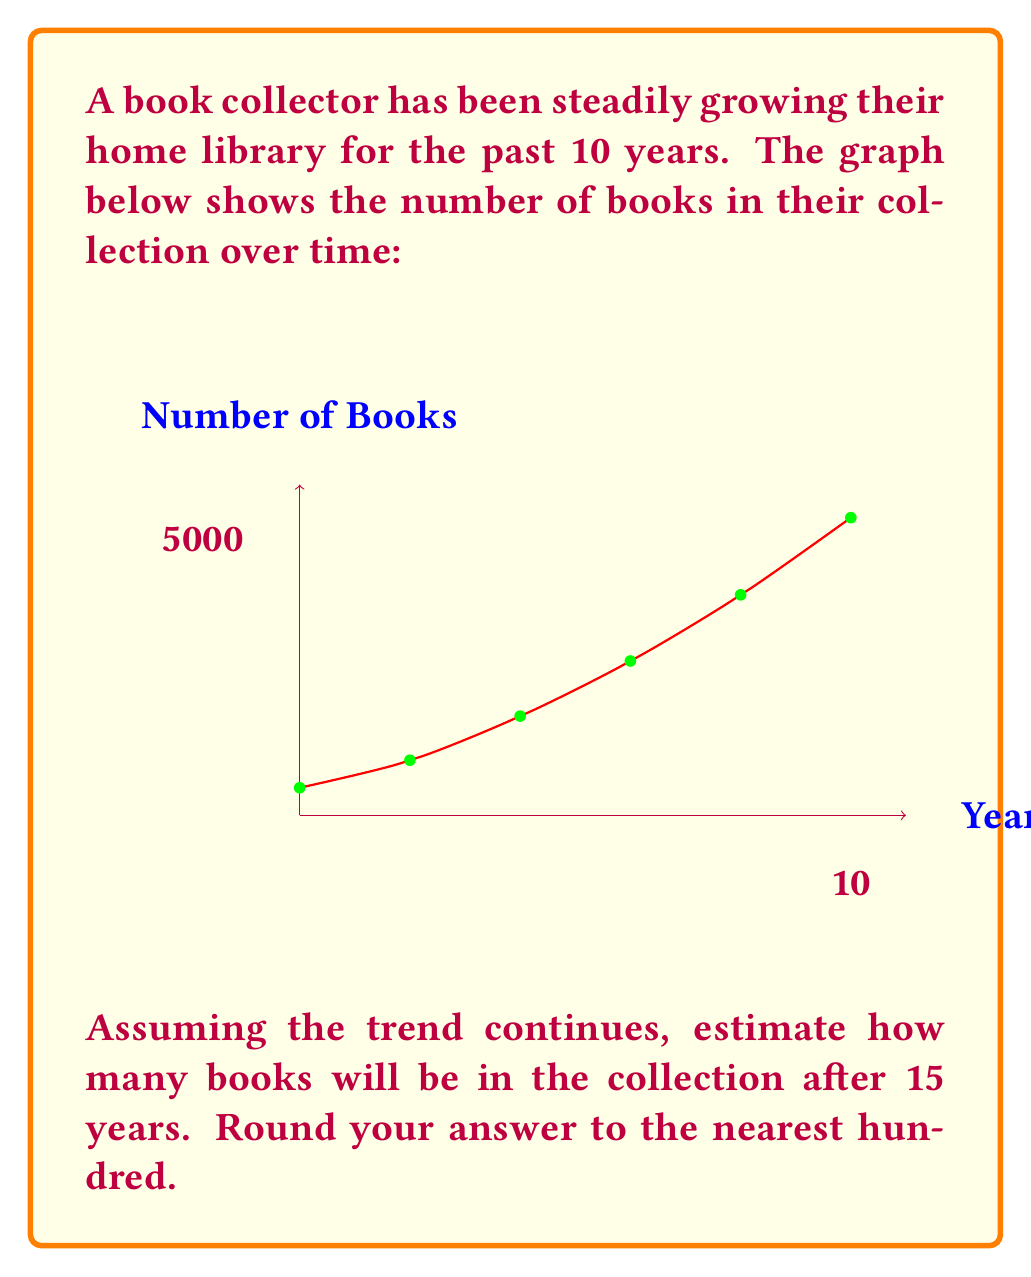Can you solve this math problem? To solve this problem, we'll follow these steps:

1) First, we need to recognize that the growth is not linear, but exponential. The rate of book acquisition is increasing over time.

2) We can model this growth using an exponential function of the form:

   $$N(t) = N_0 \cdot e^{rt}$$

   where $N(t)$ is the number of books at time $t$, $N_0$ is the initial number of books, $r$ is the growth rate, and $t$ is the time in years.

3) We can use the initial and final points to solve for $r$:

   $$5400 = 500 \cdot e^{10r}$$

4) Solving for $r$:

   $$\ln(5400/500) = 10r$$
   $$r = \frac{\ln(10.8)}{10} \approx 0.2377$$

5) Now we have our complete function:

   $$N(t) = 500 \cdot e^{0.2377t}$$

6) To find the number of books after 15 years, we plug in $t=15$:

   $$N(15) = 500 \cdot e^{0.2377 \cdot 15} \approx 9821.67$$

7) Rounding to the nearest hundred gives us 9800 books.
Answer: 9800 books 